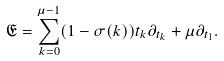Convert formula to latex. <formula><loc_0><loc_0><loc_500><loc_500>\mathfrak { E } & = \sum _ { k = 0 } ^ { \mu - 1 } ( 1 - \sigma ( k ) ) t _ { k } \partial _ { t _ { k } } + \mu \partial _ { t _ { 1 } } .</formula> 